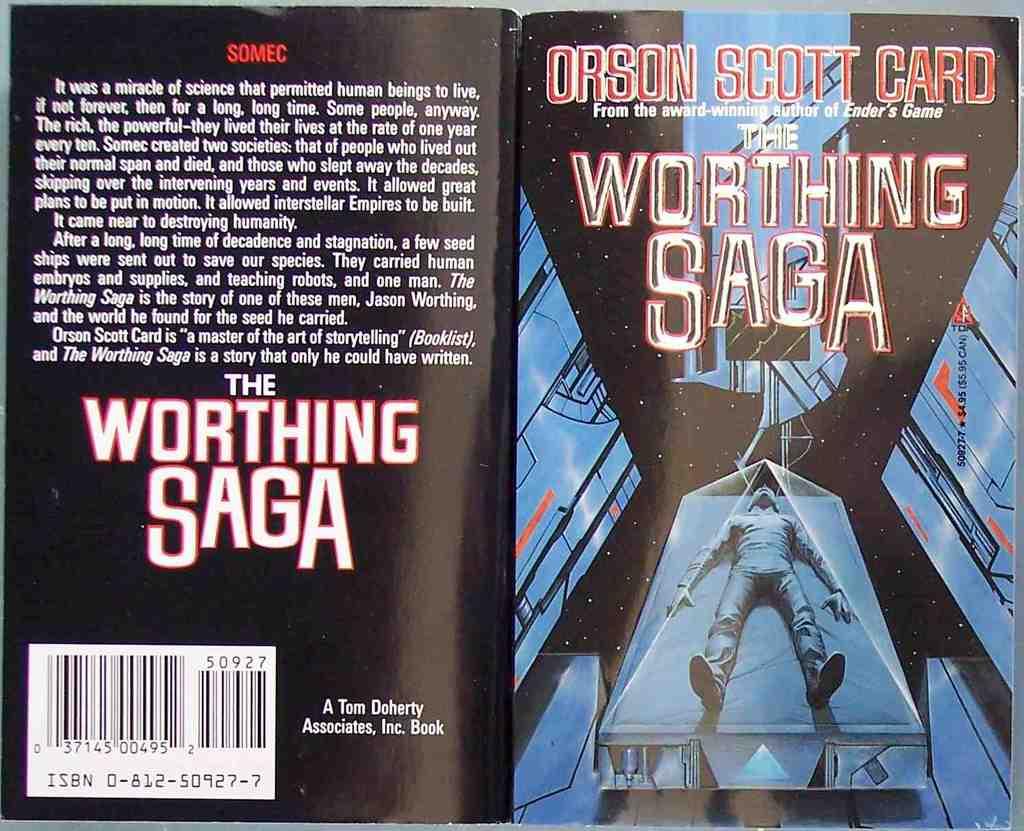What other books has orson scott card write?
Make the answer very short. Ender's game. What is the title of the book/?
Your response must be concise. The worthing saga. 